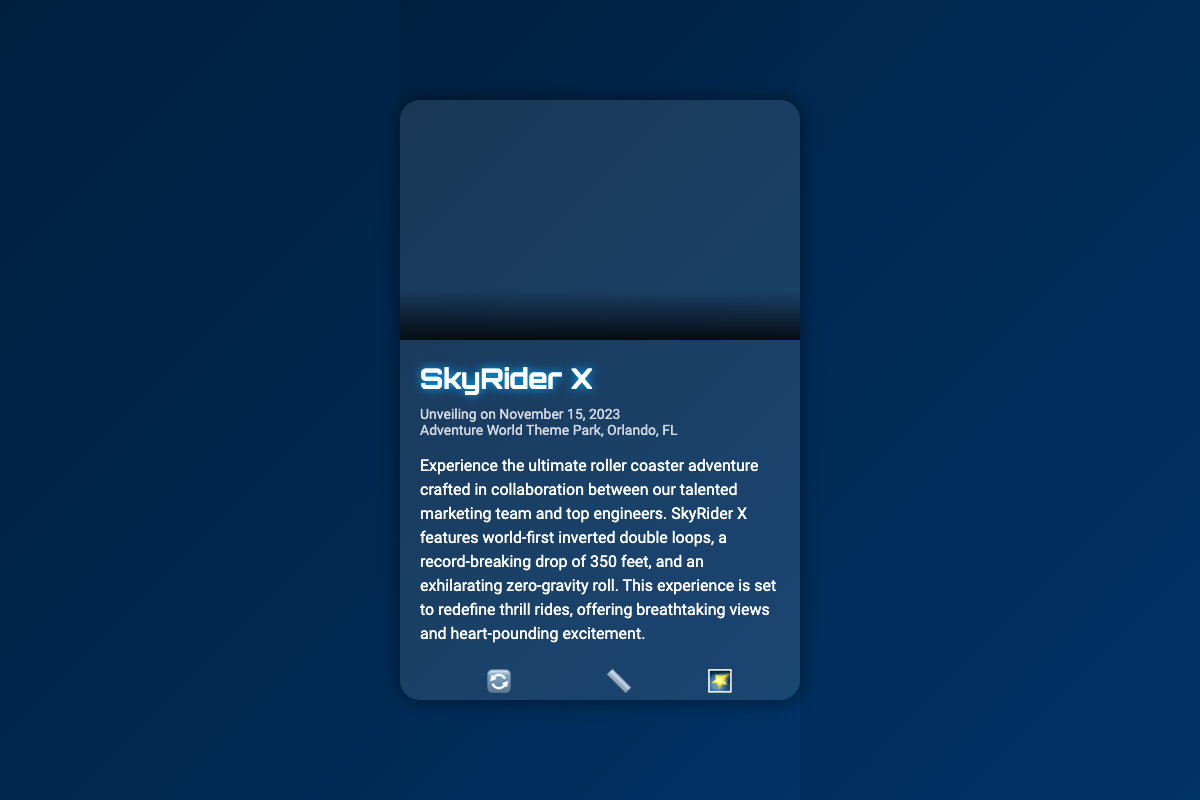what is the name of the roller coaster? The name of the roller coaster is highlighted prominently in the document.
Answer: SkyRider X what is the date of the unveiling event? The date of the unveiling event is mentioned in the document's event details section.
Answer: November 15, 2023 where is the unveiling event taking place? The location of the unveiling event is specified in the event details section of the document.
Answer: Adventure World Theme Park, Orlando, FL what is the height of the drop on SkyRider X? The height of the drop is indicated in the description section of the document.
Answer: 350ft what unique feature does SkyRider X include that involves loops? The document lists specific features of the roller coaster, including loops.
Answer: Inverted Double Loops how many unique features are highlighted in the card? The card specifically mentions a set number of unique features under the features section.
Answer: 3 what is the primary purpose of this business card? The main purpose of the card can be deduced by its content and layout related to the roller coaster on display.
Answer: Marketing what format is the call to action presented in? The call to action is presented as a button in the document to encourage user interaction.
Answer: RESERVE YOUR RIDE which font style is used for the title of the roller coaster? The style used for the title can be found within the CSS styles applied in the document.
Answer: Orbitron 